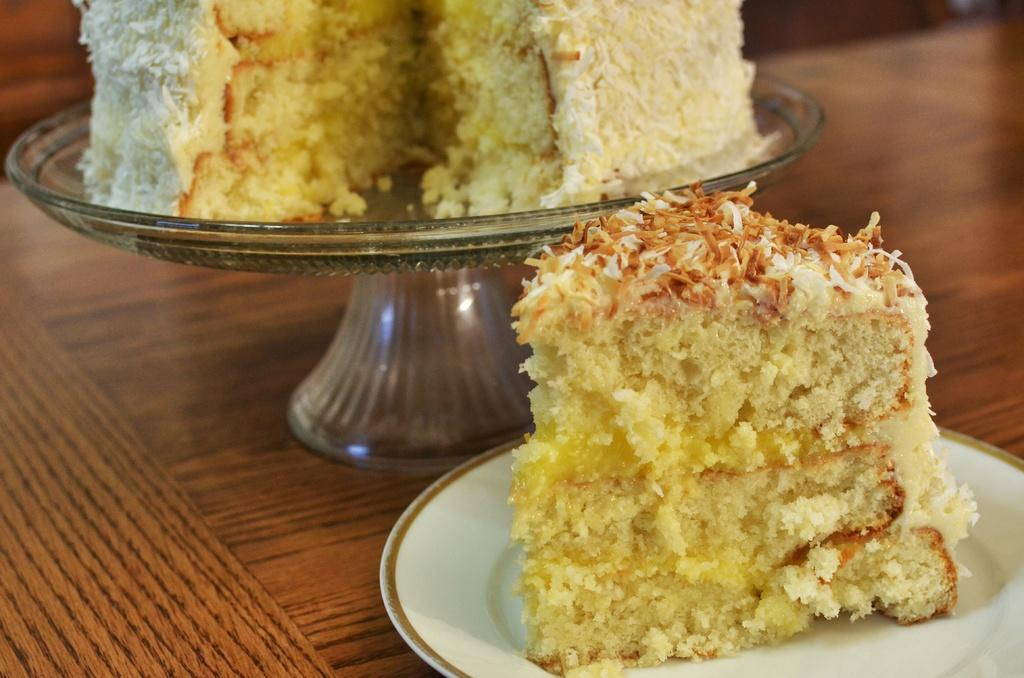What is the color of the plate that holds the food items in the image? The plate that holds the food items is white in color. Are there any other objects in the image that hold food items? Yes, there are food items on another object in the image. What type of surface are the objects placed on? The objects are placed on a wooden surface. How many kittens are sitting on the wooden surface in the image? There are no kittens present in the image; it only features food items on a plate and another object. 